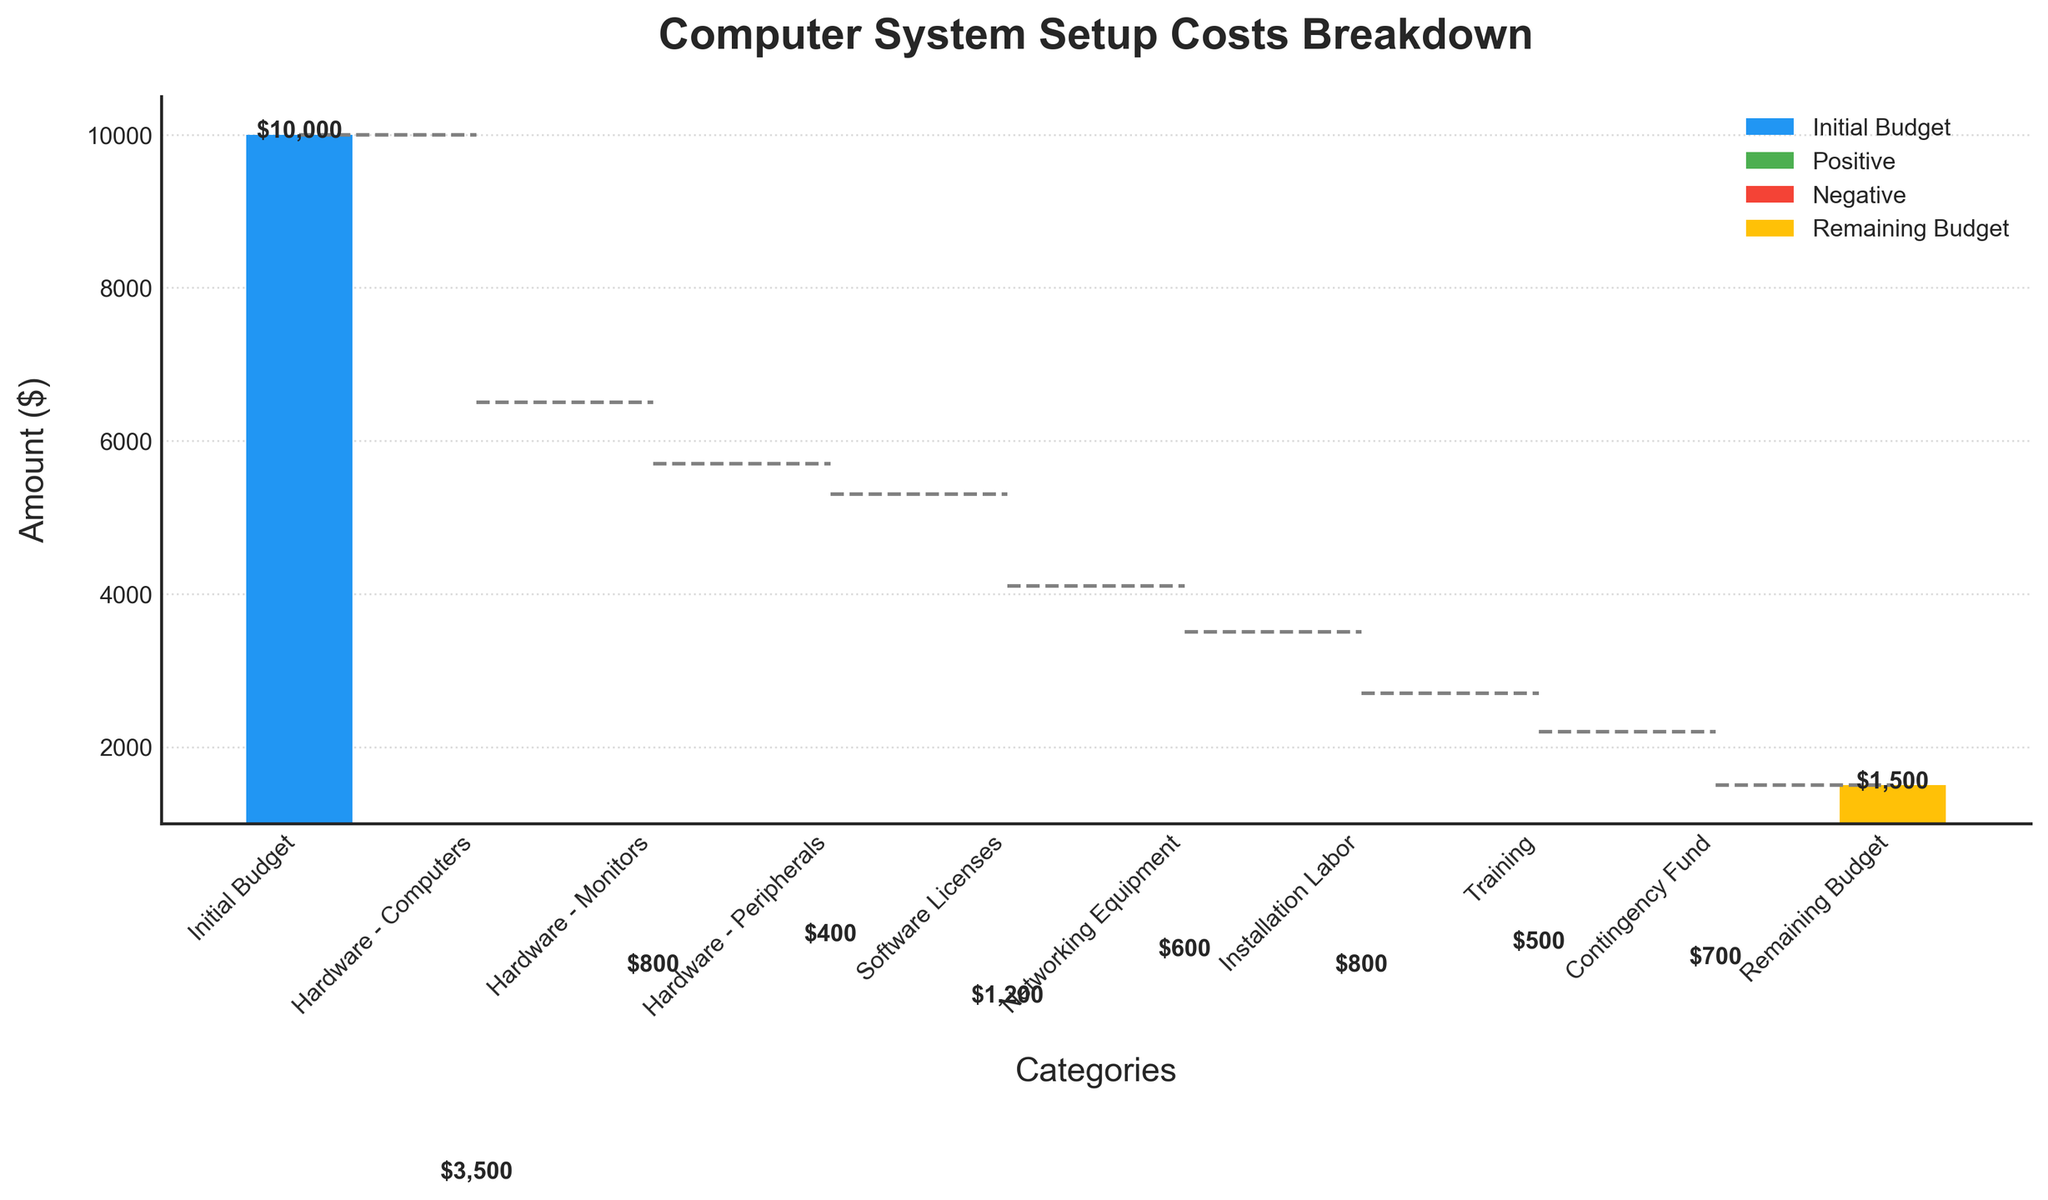What is the title of the chart? The title is specified at the top of the chart. It summarizes the purpose of the chart.
Answer: Computer System Setup Costs Breakdown How many categories are displayed on the x-axis? Each bar on the x-axis represents a category. Count all the different categories listed along the x-axis.
Answer: 10 What is the total cost of hardware (computers, monitors, and peripherals)? Add the values of all hardware components: -3500 (computers) + -800 (monitors) + -400 (peripherals).
Answer: -4700 What's the difference in cost between the initial budget and the remaining budget? Subtract the value of the remaining budget from the initial budget: 10000 - 1500.
Answer: 8500 Which category has the smallest negative value? Compare all the negative values (excluding the initial budget and remaining budget). The smallest negative value is the least costly item.
Answer: Hardware - Peripherals Which category contributes the most to the cost reduction after the initial budget? Identify the bar with the largest negative value after the initial budget.
Answer: Hardware - Computers What is the cumulative cost up to the networking equipment? Sum the values from the initial budget to the networking equipment: 10000 - 3500 - 800 - 400 - 1200 - 600.
Answer: 3500 By how much does the contingency fund affect the remaining budget? The contingency fund is a negative value that subtracts from the budget.
Answer: -700 What color represents the remaining budget in the chart? The remaining budget is specified in the code and visible in the chart.
Answer: Yellow What’s the net expenditure on setting up the computer system? Calculate net expenditure by subtracting the remaining budget from the initial budget. 10000 - 1500
Answer: 8500 